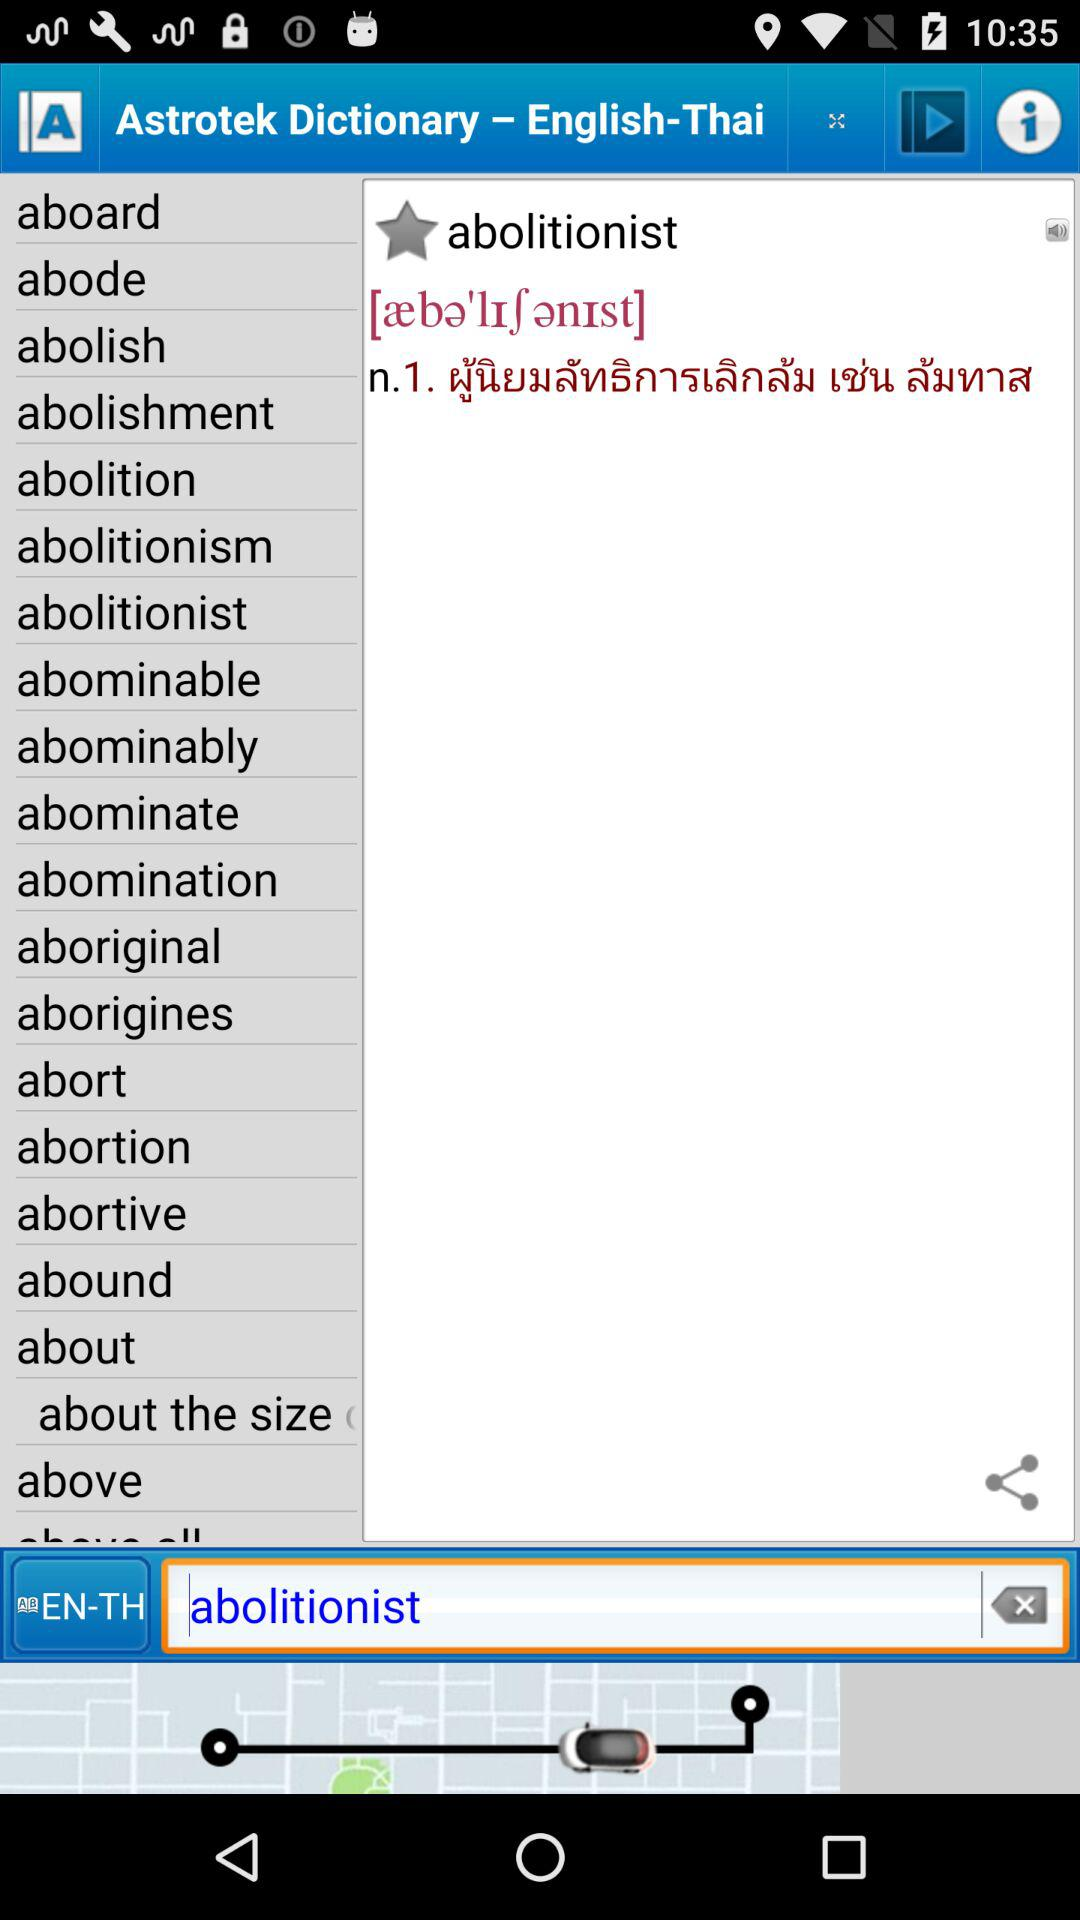How many definitions are there of "abode"?
When the provided information is insufficient, respond with <no answer>. <no answer> 